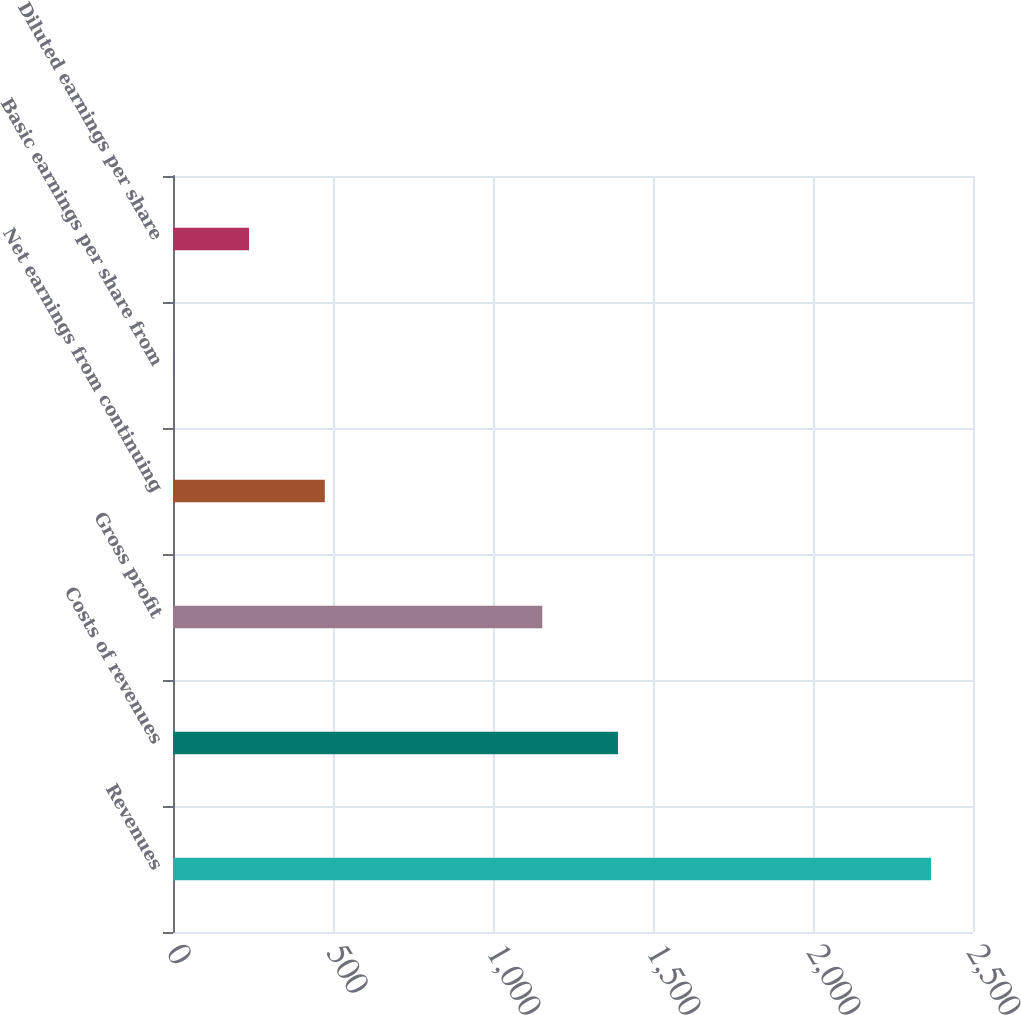Convert chart. <chart><loc_0><loc_0><loc_500><loc_500><bar_chart><fcel>Revenues<fcel>Costs of revenues<fcel>Gross profit<fcel>Net earnings from continuing<fcel>Basic earnings per share from<fcel>Diluted earnings per share<nl><fcel>2368.7<fcel>1390.79<fcel>1154<fcel>474.38<fcel>0.8<fcel>237.59<nl></chart> 